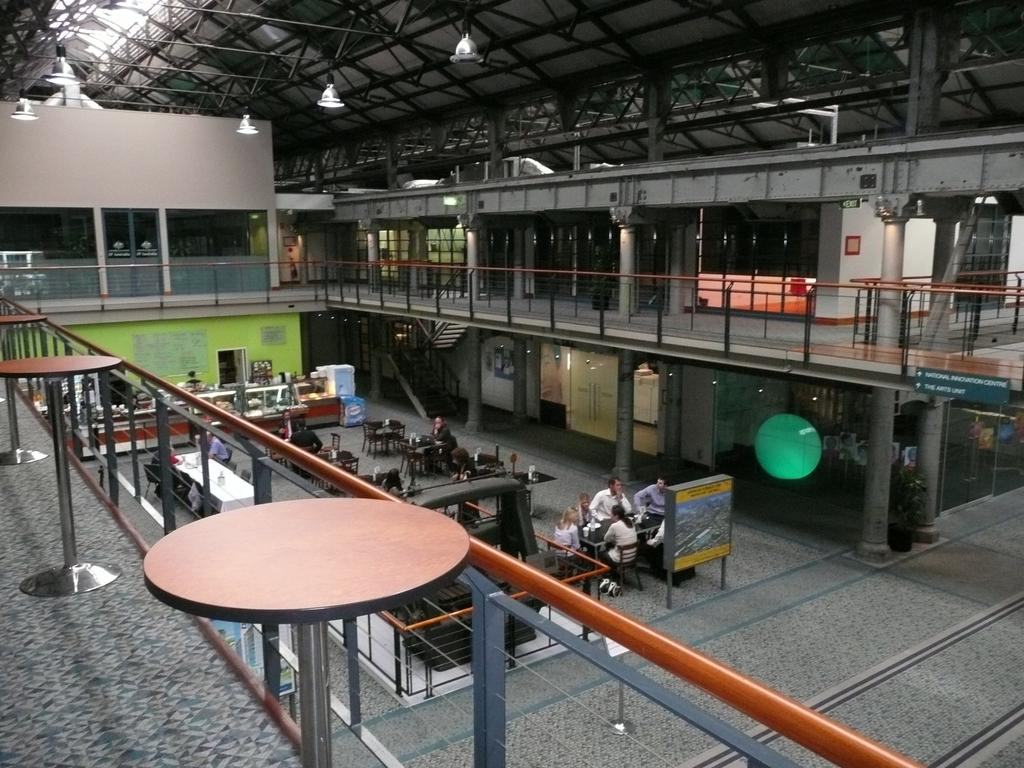What are the people in the image doing? The people in the image are sitting on chairs on the ground. What type of furniture is present in the image? There are tables in the image. What architectural features can be seen in the image? There are pillars and a staircase in the image. What can be used for illumination in the image? There are lights in the image. Can you describe the unspecified objects in the image? Unfortunately, the provided facts do not specify the nature of the unspecified objects in the image. How many men are present in the image? There is no mention of men in the image, only people sitting on chairs. How long does it take for the minute hand to move around the clock in the image? There is no clock present in the image, so it is impossible to determine the movement of the minute hand. 